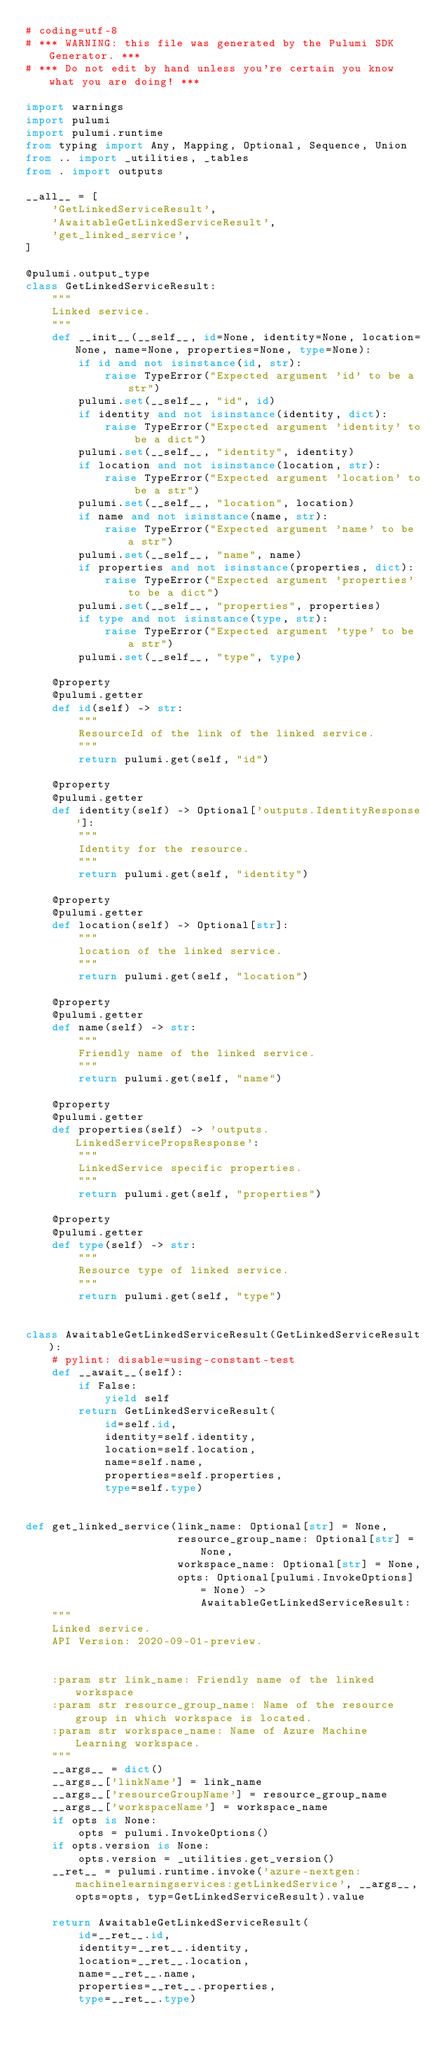Convert code to text. <code><loc_0><loc_0><loc_500><loc_500><_Python_># coding=utf-8
# *** WARNING: this file was generated by the Pulumi SDK Generator. ***
# *** Do not edit by hand unless you're certain you know what you are doing! ***

import warnings
import pulumi
import pulumi.runtime
from typing import Any, Mapping, Optional, Sequence, Union
from .. import _utilities, _tables
from . import outputs

__all__ = [
    'GetLinkedServiceResult',
    'AwaitableGetLinkedServiceResult',
    'get_linked_service',
]

@pulumi.output_type
class GetLinkedServiceResult:
    """
    Linked service.
    """
    def __init__(__self__, id=None, identity=None, location=None, name=None, properties=None, type=None):
        if id and not isinstance(id, str):
            raise TypeError("Expected argument 'id' to be a str")
        pulumi.set(__self__, "id", id)
        if identity and not isinstance(identity, dict):
            raise TypeError("Expected argument 'identity' to be a dict")
        pulumi.set(__self__, "identity", identity)
        if location and not isinstance(location, str):
            raise TypeError("Expected argument 'location' to be a str")
        pulumi.set(__self__, "location", location)
        if name and not isinstance(name, str):
            raise TypeError("Expected argument 'name' to be a str")
        pulumi.set(__self__, "name", name)
        if properties and not isinstance(properties, dict):
            raise TypeError("Expected argument 'properties' to be a dict")
        pulumi.set(__self__, "properties", properties)
        if type and not isinstance(type, str):
            raise TypeError("Expected argument 'type' to be a str")
        pulumi.set(__self__, "type", type)

    @property
    @pulumi.getter
    def id(self) -> str:
        """
        ResourceId of the link of the linked service.
        """
        return pulumi.get(self, "id")

    @property
    @pulumi.getter
    def identity(self) -> Optional['outputs.IdentityResponse']:
        """
        Identity for the resource.
        """
        return pulumi.get(self, "identity")

    @property
    @pulumi.getter
    def location(self) -> Optional[str]:
        """
        location of the linked service.
        """
        return pulumi.get(self, "location")

    @property
    @pulumi.getter
    def name(self) -> str:
        """
        Friendly name of the linked service.
        """
        return pulumi.get(self, "name")

    @property
    @pulumi.getter
    def properties(self) -> 'outputs.LinkedServicePropsResponse':
        """
        LinkedService specific properties.
        """
        return pulumi.get(self, "properties")

    @property
    @pulumi.getter
    def type(self) -> str:
        """
        Resource type of linked service.
        """
        return pulumi.get(self, "type")


class AwaitableGetLinkedServiceResult(GetLinkedServiceResult):
    # pylint: disable=using-constant-test
    def __await__(self):
        if False:
            yield self
        return GetLinkedServiceResult(
            id=self.id,
            identity=self.identity,
            location=self.location,
            name=self.name,
            properties=self.properties,
            type=self.type)


def get_linked_service(link_name: Optional[str] = None,
                       resource_group_name: Optional[str] = None,
                       workspace_name: Optional[str] = None,
                       opts: Optional[pulumi.InvokeOptions] = None) -> AwaitableGetLinkedServiceResult:
    """
    Linked service.
    API Version: 2020-09-01-preview.


    :param str link_name: Friendly name of the linked workspace
    :param str resource_group_name: Name of the resource group in which workspace is located.
    :param str workspace_name: Name of Azure Machine Learning workspace.
    """
    __args__ = dict()
    __args__['linkName'] = link_name
    __args__['resourceGroupName'] = resource_group_name
    __args__['workspaceName'] = workspace_name
    if opts is None:
        opts = pulumi.InvokeOptions()
    if opts.version is None:
        opts.version = _utilities.get_version()
    __ret__ = pulumi.runtime.invoke('azure-nextgen:machinelearningservices:getLinkedService', __args__, opts=opts, typ=GetLinkedServiceResult).value

    return AwaitableGetLinkedServiceResult(
        id=__ret__.id,
        identity=__ret__.identity,
        location=__ret__.location,
        name=__ret__.name,
        properties=__ret__.properties,
        type=__ret__.type)
</code> 